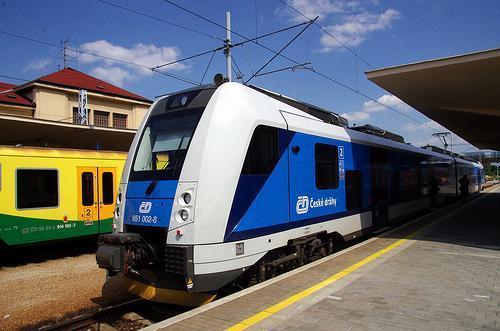How many trains are there?
Give a very brief answer. 2. 